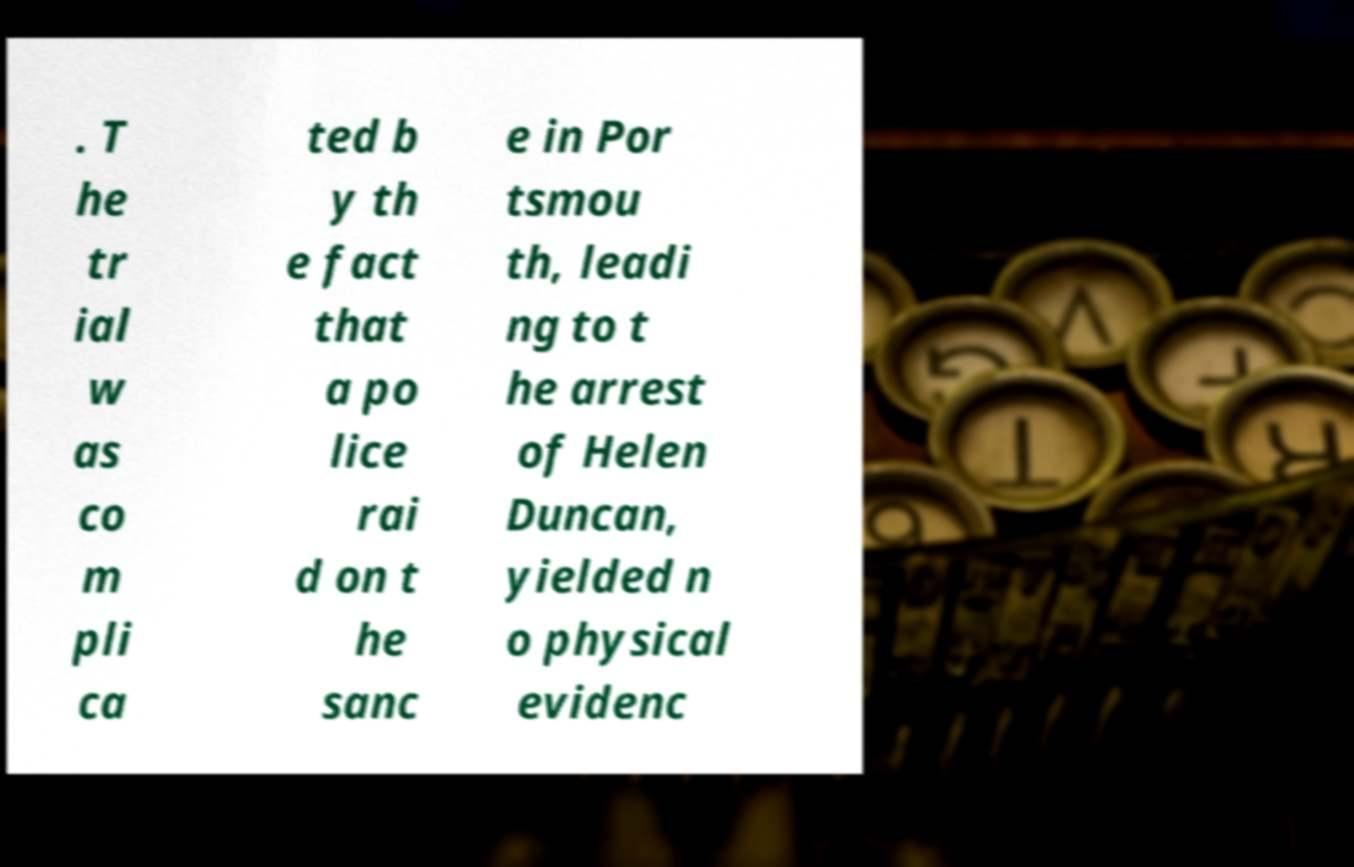Can you accurately transcribe the text from the provided image for me? . T he tr ial w as co m pli ca ted b y th e fact that a po lice rai d on t he sanc e in Por tsmou th, leadi ng to t he arrest of Helen Duncan, yielded n o physical evidenc 